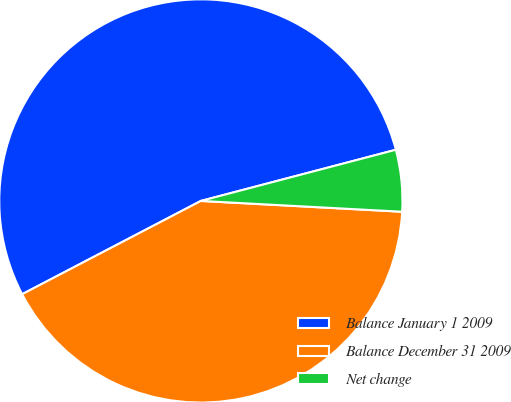Convert chart to OTSL. <chart><loc_0><loc_0><loc_500><loc_500><pie_chart><fcel>Balance January 1 2009<fcel>Balance December 31 2009<fcel>Net change<nl><fcel>53.57%<fcel>41.49%<fcel>4.94%<nl></chart> 